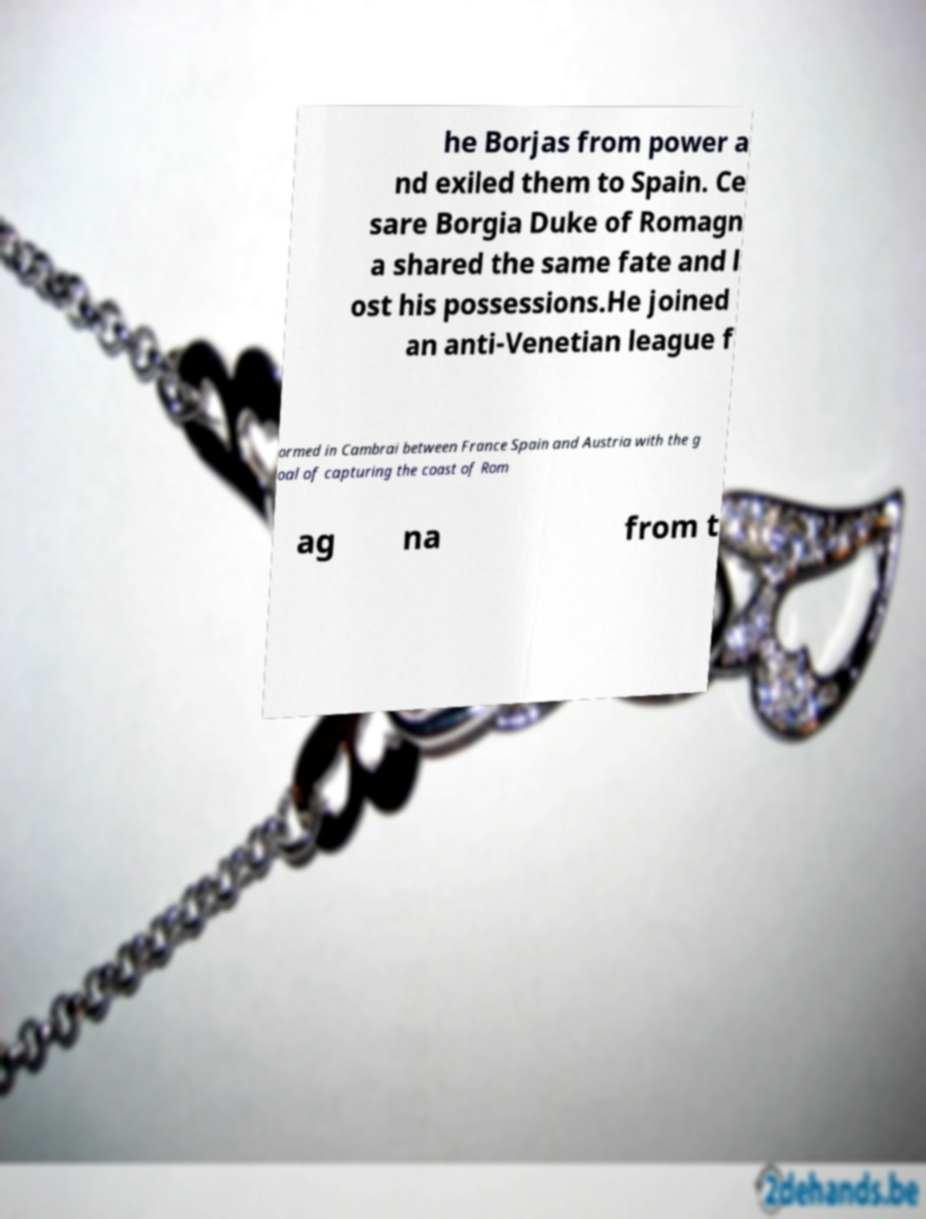What messages or text are displayed in this image? I need them in a readable, typed format. he Borjas from power a nd exiled them to Spain. Ce sare Borgia Duke of Romagn a shared the same fate and l ost his possessions.He joined an anti-Venetian league f ormed in Cambrai between France Spain and Austria with the g oal of capturing the coast of Rom ag na from t 